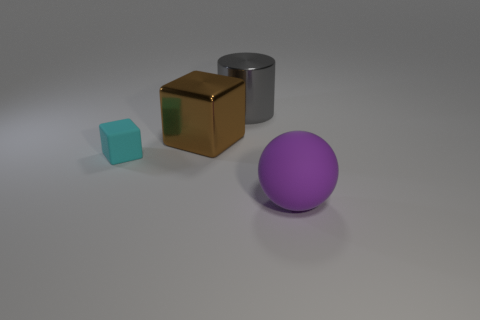Add 4 brown shiny cubes. How many objects exist? 8 Subtract all spheres. How many objects are left? 3 Add 2 large gray objects. How many large gray objects are left? 3 Add 2 cyan matte objects. How many cyan matte objects exist? 3 Subtract 0 blue cubes. How many objects are left? 4 Subtract all cylinders. Subtract all large brown blocks. How many objects are left? 2 